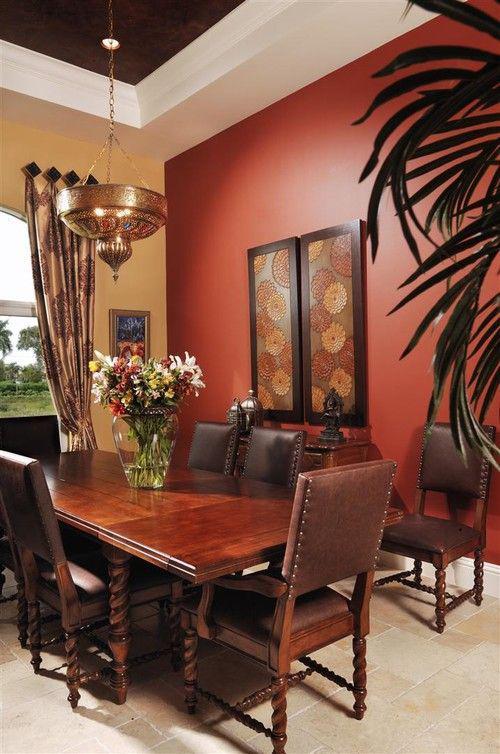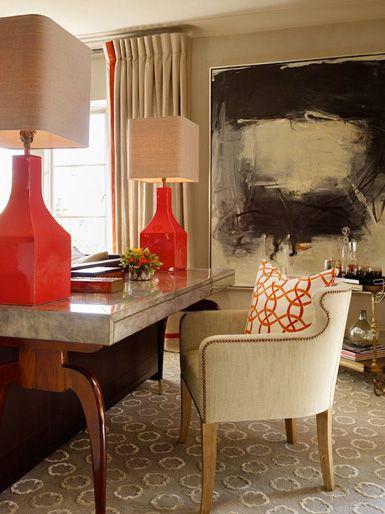The first image is the image on the left, the second image is the image on the right. Considering the images on both sides, is "The left image features two bar stools pulled up to a counter with three lights hanging over it." valid? Answer yes or no. No. The first image is the image on the left, the second image is the image on the right. Assess this claim about the two images: "In at least one image there are three hanging light over a kitchen island.". Correct or not? Answer yes or no. No. 